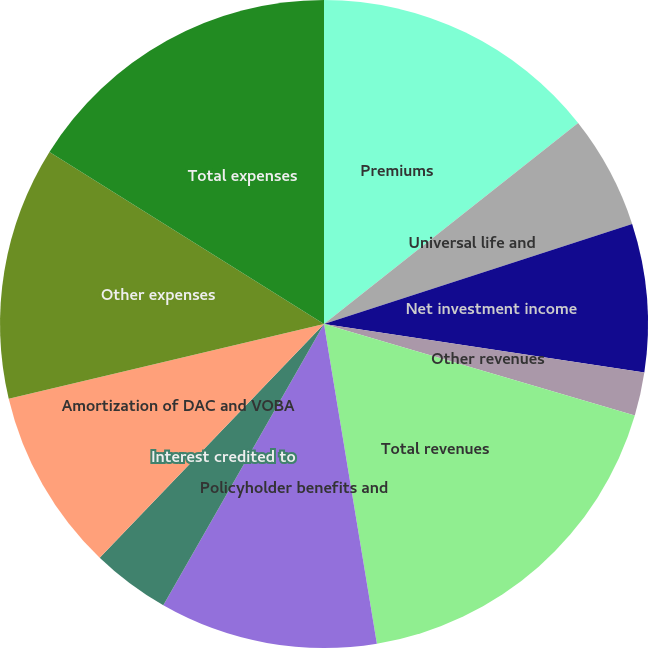Convert chart. <chart><loc_0><loc_0><loc_500><loc_500><pie_chart><fcel>Premiums<fcel>Universal life and<fcel>Net investment income<fcel>Other revenues<fcel>Total revenues<fcel>Policyholder benefits and<fcel>Interest credited to<fcel>Amortization of DAC and VOBA<fcel>Other expenses<fcel>Total expenses<nl><fcel>14.35%<fcel>5.65%<fcel>7.39%<fcel>2.17%<fcel>17.83%<fcel>10.87%<fcel>3.91%<fcel>9.13%<fcel>12.61%<fcel>16.09%<nl></chart> 